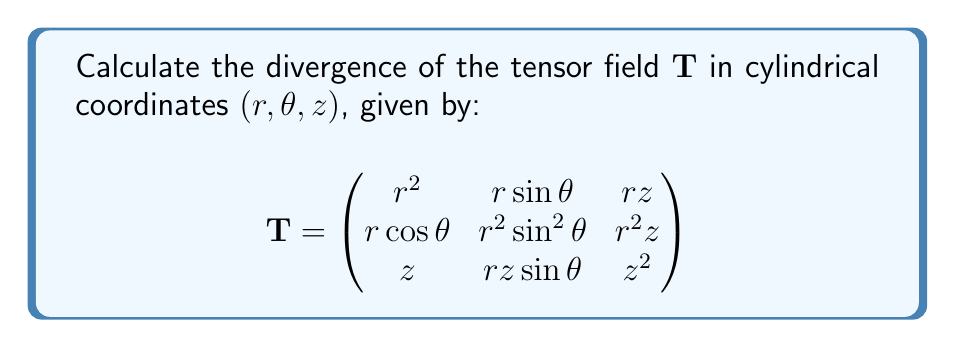Solve this math problem. To compute the divergence of a tensor field in cylindrical coordinates, we use the formula:

$$\nabla \cdot \mathbf{T} = \frac{1}{r}\frac{\partial(r T_{rr})}{\partial r} + \frac{1}{r}\frac{\partial T_{\theta r}}{\partial \theta} + \frac{\partial T_{zr}}{\partial z} + \frac{T_{rr}}{r} + \frac{1}{r}\frac{\partial(r T_{r\theta})}{\partial r} + \frac{1}{r}\frac{\partial T_{\theta\theta}}{\partial \theta} + \frac{\partial T_{z\theta}}{\partial z} + \frac{1}{r}\frac{\partial(r T_{rz})}{\partial r} + \frac{1}{r}\frac{\partial T_{\theta z}}{\partial \theta} + \frac{\partial T_{zz}}{\partial z}$$

Let's calculate each term:

1) $\frac{1}{r}\frac{\partial(r T_{rr})}{\partial r} = \frac{1}{r}\frac{\partial(r \cdot r^2)}{\partial r} = \frac{1}{r}\frac{\partial(r^3)}{\partial r} = \frac{1}{r} \cdot 3r^2 = 3r$

2) $\frac{1}{r}\frac{\partial T_{\theta r}}{\partial \theta} = \frac{1}{r}\frac{\partial(r\cos\theta)}{\partial \theta} = -\sin\theta$

3) $\frac{\partial T_{zr}}{\partial z} = \frac{\partial z}{\partial z} = 1$

4) $\frac{T_{rr}}{r} = \frac{r^2}{r} = r$

5) $\frac{1}{r}\frac{\partial(r T_{r\theta})}{\partial r} = \frac{1}{r}\frac{\partial(r \cdot r\sin\theta)}{\partial r} = \frac{1}{r}\frac{\partial(r^2\sin\theta)}{\partial r} = 2\sin\theta$

6) $\frac{1}{r}\frac{\partial T_{\theta\theta}}{\partial \theta} = \frac{1}{r}\frac{\partial(r^2\sin^2\theta)}{\partial \theta} = 2r\sin\theta\cos\theta$

7) $\frac{\partial T_{z\theta}}{\partial z} = \frac{\partial(rz\sin\theta)}{\partial z} = r\sin\theta$

8) $\frac{1}{r}\frac{\partial(r T_{rz})}{\partial r} = \frac{1}{r}\frac{\partial(r \cdot rz)}{\partial r} = \frac{1}{r}\frac{\partial(r^2z)}{\partial r} = 2z$

9) $\frac{1}{r}\frac{\partial T_{\theta z}}{\partial \theta} = \frac{1}{r}\frac{\partial(r^2z)}{\partial \theta} = 0$

10) $\frac{\partial T_{zz}}{\partial z} = \frac{\partial z^2}{\partial z} = 2z$

Now, we sum all these terms:

$$\nabla \cdot \mathbf{T} = 3r - \sin\theta + 1 + r + 2\sin\theta + 2r\sin\theta\cos\theta + r\sin\theta + 2z + 0 + 2z$$

Simplifying:

$$\nabla \cdot \mathbf{T} = 4r + \sin\theta(1 + 2r\cos\theta) + 4z + 1$$
Answer: $4r + \sin\theta(1 + 2r\cos\theta) + 4z + 1$ 